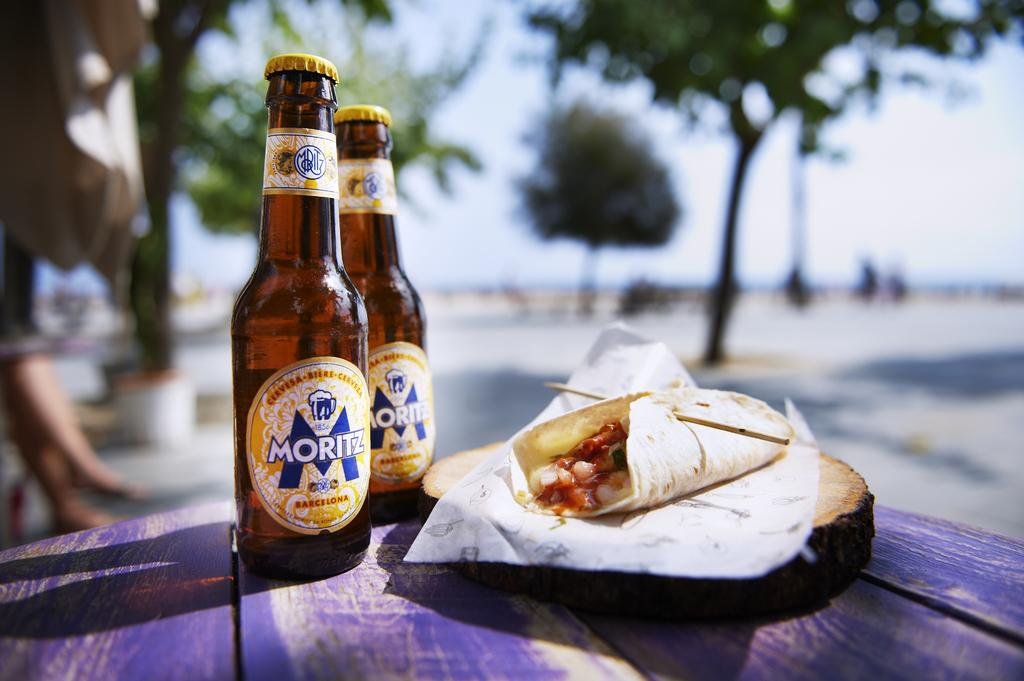What type of beverages are present in the image? There are two beer bottles in the image. What else can be seen on the table besides the beer bottles? There is food on the table in the image. What can be seen in the background of the image? Trees are visible in the image. What type of underwear is the sister wearing in the image? There is no sister or underwear present in the image. 